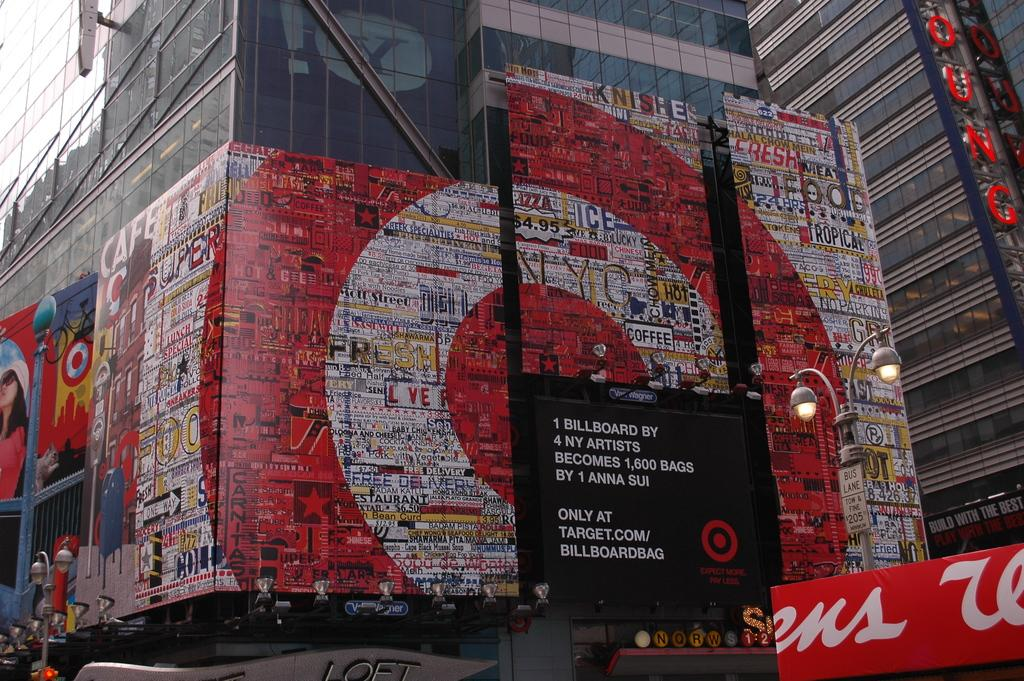<image>
Render a clear and concise summary of the photo. A target store lines the streets of a big city. 